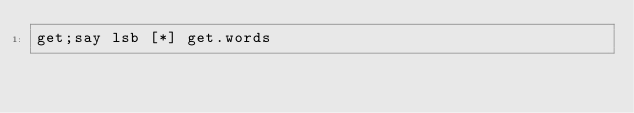Convert code to text. <code><loc_0><loc_0><loc_500><loc_500><_Perl_>get;say lsb [*] get.words</code> 